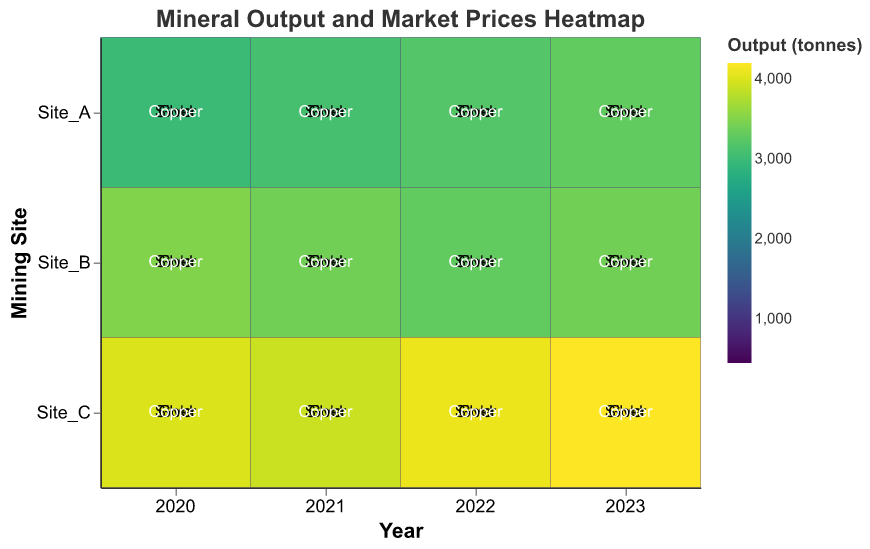What is the title of the heatmap? The title of the heatmap is indicated at the top and reads "Mineral Output and Market Prices Heatmap"
Answer: Mineral Output and Market Prices Heatmap Which site had the highest gold output in 2023? In 2023, Site_C had the highest gold output, indicated by the darkest rectangle in the column for 2023 and the row for Site_C.
Answer: Site_C What is the change in the output of silver from 2021 to 2023 at Site_B? To find the change in output, subtract the 2021 silver output value from the 2023 silver output value for Site_B. For 2021, it was 1250 tonnes, and for 2023, it was 1350 tonnes. Therefore, 1350 - 1250 = 100 tonnes.
Answer: 100 tonnes Which mineral had the highest output in 2023 and from which site? In 2023, the mineral copper had the highest output, and it was from Site_C as indicated by the darkest cell in the 2023 column for Site_C.
Answer: Copper, Site_C Did Site_A increase or decrease its gold output from 2020 to 2023? Compare the gold output values for Site_A in 2020 and 2023. In 2020, it was 500 tonnes, and in 2023, it increased to 570 tonnes. This indicates an increase.
Answer: Increase Compare the market price trend of copper between Site_A and Site_B from 2020 to 2023. Examine the values of Market_Price_per_tonne for copper across the years 2020 to 2023 for both Site_A and Site_B. Site_A: 6200 (2020), 6500 (2021), 6600 (2022), 6800 (2023). Site_B: 6300 (2020), 6400 (2021), 6700 (2022), 6900 (2023). Both sites show an increasing trend, with Site_B having a generally higher rate of increase each year.
Answer: Both sites have an increasing trend, Site_B increases more rapidly Which year had the least output for silver at Site_C? Look at the gradients of the colors representing output values for silver at Site_C across all years. 2020 had the lightest color, indicating the least output. In 2020, the output was 900 tonnes.
Answer: 2020 What is the visual representation used to indicate the magnitude of output in this heatmap? The heatmap uses color gradients to represent different magnitudes of output, with darker colors indicating higher output values and lighter colors indicating lower output values.
Answer: Color gradients How does the copper output in 2022 at Site_C compare to Site_B? Check the color intensity and the numeric values for copper output in 2022 for both sites. For Site_C, it was 4100 tonnes, while for Site_B, it was 3300 tonnes, indicating that Site_C had a higher output.
Answer: Site_C had a higher output Which site had an increase in silver output in each consecutive year from 2020 to 2023? Observe the silver output across Site_A, Site_B, and Site_C for each year. Site_A had increasing silver output: 1000 (2020), 1050 (2021), 1100 (2022), 1150 (2023). Thus, Site_A had a consistent increase in silver output each year.
Answer: Site_A 